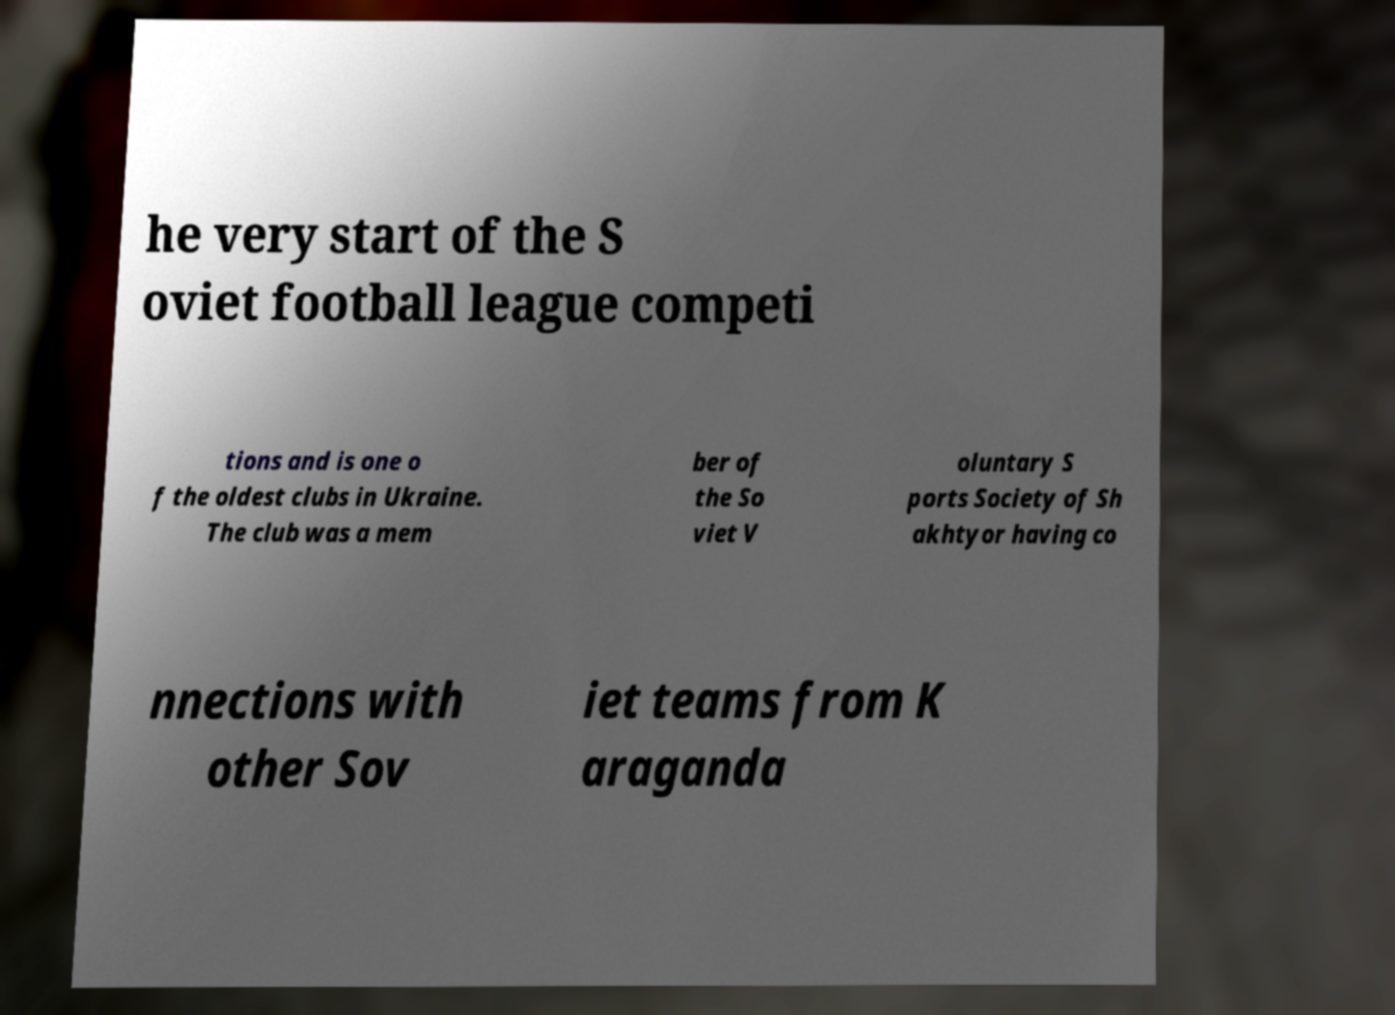I need the written content from this picture converted into text. Can you do that? he very start of the S oviet football league competi tions and is one o f the oldest clubs in Ukraine. The club was a mem ber of the So viet V oluntary S ports Society of Sh akhtyor having co nnections with other Sov iet teams from K araganda 